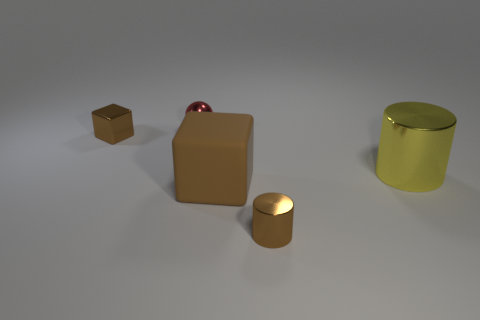Is the color of the big cube the same as the small metallic block?
Make the answer very short. Yes. Do the object to the left of the small red thing and the small cylinder have the same color?
Your response must be concise. Yes. The tiny metal object that is the same color as the small metal cube is what shape?
Give a very brief answer. Cylinder. What number of big yellow blocks have the same material as the tiny cylinder?
Offer a very short reply. 0. There is a red shiny sphere; what number of metallic objects are in front of it?
Offer a very short reply. 3. What size is the ball?
Provide a short and direct response. Small. The shiny cylinder that is the same size as the sphere is what color?
Your answer should be very brief. Brown. Is there a tiny cube that has the same color as the matte thing?
Offer a terse response. Yes. What is the small red object made of?
Make the answer very short. Metal. How many tiny red metallic objects are there?
Offer a terse response. 1. 